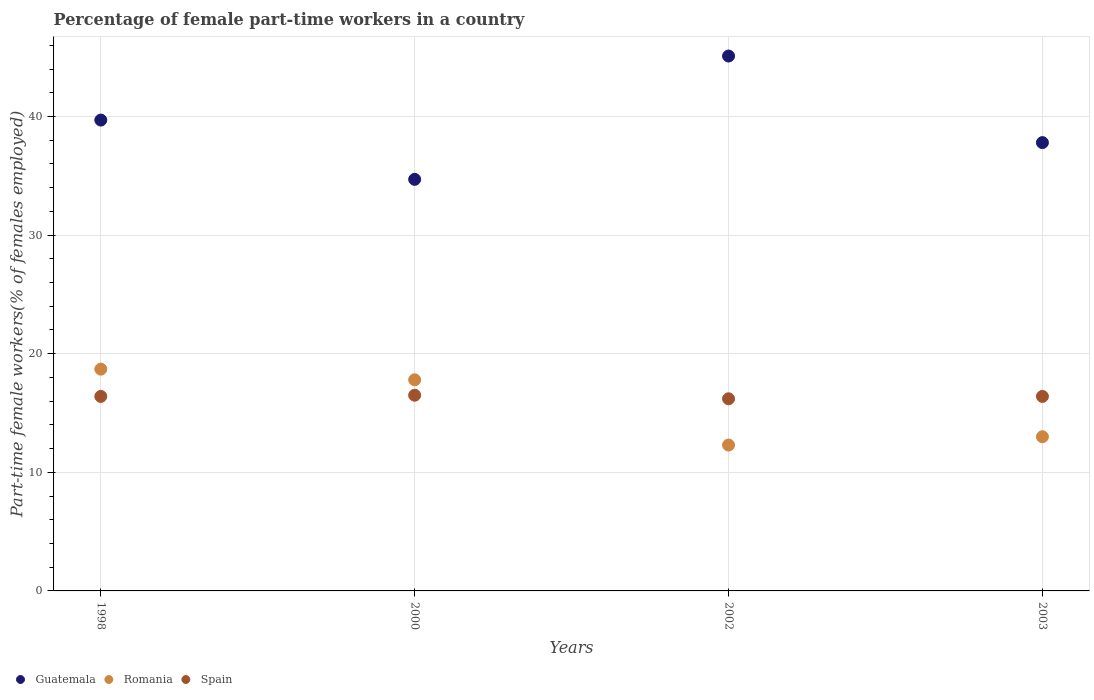What is the percentage of female part-time workers in Guatemala in 2000?
Offer a very short reply. 34.7. Across all years, what is the maximum percentage of female part-time workers in Romania?
Make the answer very short. 18.7. Across all years, what is the minimum percentage of female part-time workers in Guatemala?
Your response must be concise. 34.7. In which year was the percentage of female part-time workers in Guatemala minimum?
Provide a succinct answer. 2000. What is the total percentage of female part-time workers in Spain in the graph?
Provide a succinct answer. 65.5. What is the difference between the percentage of female part-time workers in Romania in 1998 and that in 2003?
Offer a very short reply. 5.7. What is the difference between the percentage of female part-time workers in Spain in 2002 and the percentage of female part-time workers in Romania in 2000?
Your answer should be compact. -1.6. What is the average percentage of female part-time workers in Romania per year?
Keep it short and to the point. 15.45. In the year 2002, what is the difference between the percentage of female part-time workers in Romania and percentage of female part-time workers in Guatemala?
Make the answer very short. -32.8. What is the ratio of the percentage of female part-time workers in Guatemala in 2002 to that in 2003?
Your response must be concise. 1.19. Is the percentage of female part-time workers in Guatemala in 1998 less than that in 2003?
Provide a short and direct response. No. What is the difference between the highest and the second highest percentage of female part-time workers in Spain?
Ensure brevity in your answer.  0.1. What is the difference between the highest and the lowest percentage of female part-time workers in Guatemala?
Offer a very short reply. 10.4. Is it the case that in every year, the sum of the percentage of female part-time workers in Spain and percentage of female part-time workers in Romania  is greater than the percentage of female part-time workers in Guatemala?
Offer a terse response. No. Is the percentage of female part-time workers in Spain strictly greater than the percentage of female part-time workers in Romania over the years?
Offer a terse response. No. How many years are there in the graph?
Make the answer very short. 4. Does the graph contain any zero values?
Your answer should be very brief. No. Where does the legend appear in the graph?
Give a very brief answer. Bottom left. What is the title of the graph?
Offer a very short reply. Percentage of female part-time workers in a country. Does "Ecuador" appear as one of the legend labels in the graph?
Offer a terse response. No. What is the label or title of the Y-axis?
Give a very brief answer. Part-time female workers(% of females employed). What is the Part-time female workers(% of females employed) of Guatemala in 1998?
Offer a very short reply. 39.7. What is the Part-time female workers(% of females employed) in Romania in 1998?
Provide a short and direct response. 18.7. What is the Part-time female workers(% of females employed) of Spain in 1998?
Your answer should be compact. 16.4. What is the Part-time female workers(% of females employed) in Guatemala in 2000?
Your answer should be compact. 34.7. What is the Part-time female workers(% of females employed) in Romania in 2000?
Offer a terse response. 17.8. What is the Part-time female workers(% of females employed) in Spain in 2000?
Your answer should be compact. 16.5. What is the Part-time female workers(% of females employed) of Guatemala in 2002?
Your answer should be compact. 45.1. What is the Part-time female workers(% of females employed) of Romania in 2002?
Keep it short and to the point. 12.3. What is the Part-time female workers(% of females employed) in Spain in 2002?
Give a very brief answer. 16.2. What is the Part-time female workers(% of females employed) of Guatemala in 2003?
Keep it short and to the point. 37.8. What is the Part-time female workers(% of females employed) in Spain in 2003?
Give a very brief answer. 16.4. Across all years, what is the maximum Part-time female workers(% of females employed) of Guatemala?
Give a very brief answer. 45.1. Across all years, what is the maximum Part-time female workers(% of females employed) of Romania?
Your answer should be compact. 18.7. Across all years, what is the minimum Part-time female workers(% of females employed) of Guatemala?
Ensure brevity in your answer.  34.7. Across all years, what is the minimum Part-time female workers(% of females employed) in Romania?
Offer a very short reply. 12.3. Across all years, what is the minimum Part-time female workers(% of females employed) of Spain?
Give a very brief answer. 16.2. What is the total Part-time female workers(% of females employed) in Guatemala in the graph?
Make the answer very short. 157.3. What is the total Part-time female workers(% of females employed) in Romania in the graph?
Make the answer very short. 61.8. What is the total Part-time female workers(% of females employed) of Spain in the graph?
Your answer should be compact. 65.5. What is the difference between the Part-time female workers(% of females employed) in Romania in 1998 and that in 2002?
Your answer should be compact. 6.4. What is the difference between the Part-time female workers(% of females employed) in Guatemala in 1998 and that in 2003?
Provide a short and direct response. 1.9. What is the difference between the Part-time female workers(% of females employed) in Spain in 1998 and that in 2003?
Your response must be concise. 0. What is the difference between the Part-time female workers(% of females employed) of Guatemala in 2000 and that in 2002?
Provide a succinct answer. -10.4. What is the difference between the Part-time female workers(% of females employed) of Romania in 2000 and that in 2002?
Keep it short and to the point. 5.5. What is the difference between the Part-time female workers(% of females employed) of Spain in 2000 and that in 2002?
Provide a succinct answer. 0.3. What is the difference between the Part-time female workers(% of females employed) of Guatemala in 2002 and that in 2003?
Your answer should be compact. 7.3. What is the difference between the Part-time female workers(% of females employed) of Romania in 2002 and that in 2003?
Provide a short and direct response. -0.7. What is the difference between the Part-time female workers(% of females employed) in Spain in 2002 and that in 2003?
Your response must be concise. -0.2. What is the difference between the Part-time female workers(% of females employed) in Guatemala in 1998 and the Part-time female workers(% of females employed) in Romania in 2000?
Offer a terse response. 21.9. What is the difference between the Part-time female workers(% of females employed) of Guatemala in 1998 and the Part-time female workers(% of females employed) of Spain in 2000?
Offer a terse response. 23.2. What is the difference between the Part-time female workers(% of females employed) in Guatemala in 1998 and the Part-time female workers(% of females employed) in Romania in 2002?
Your answer should be very brief. 27.4. What is the difference between the Part-time female workers(% of females employed) in Guatemala in 1998 and the Part-time female workers(% of females employed) in Spain in 2002?
Give a very brief answer. 23.5. What is the difference between the Part-time female workers(% of females employed) in Romania in 1998 and the Part-time female workers(% of females employed) in Spain in 2002?
Your answer should be very brief. 2.5. What is the difference between the Part-time female workers(% of females employed) in Guatemala in 1998 and the Part-time female workers(% of females employed) in Romania in 2003?
Offer a terse response. 26.7. What is the difference between the Part-time female workers(% of females employed) in Guatemala in 1998 and the Part-time female workers(% of females employed) in Spain in 2003?
Make the answer very short. 23.3. What is the difference between the Part-time female workers(% of females employed) in Guatemala in 2000 and the Part-time female workers(% of females employed) in Romania in 2002?
Your answer should be very brief. 22.4. What is the difference between the Part-time female workers(% of females employed) of Guatemala in 2000 and the Part-time female workers(% of females employed) of Spain in 2002?
Make the answer very short. 18.5. What is the difference between the Part-time female workers(% of females employed) in Romania in 2000 and the Part-time female workers(% of females employed) in Spain in 2002?
Make the answer very short. 1.6. What is the difference between the Part-time female workers(% of females employed) in Guatemala in 2000 and the Part-time female workers(% of females employed) in Romania in 2003?
Keep it short and to the point. 21.7. What is the difference between the Part-time female workers(% of females employed) of Guatemala in 2000 and the Part-time female workers(% of females employed) of Spain in 2003?
Ensure brevity in your answer.  18.3. What is the difference between the Part-time female workers(% of females employed) of Guatemala in 2002 and the Part-time female workers(% of females employed) of Romania in 2003?
Your response must be concise. 32.1. What is the difference between the Part-time female workers(% of females employed) in Guatemala in 2002 and the Part-time female workers(% of females employed) in Spain in 2003?
Your answer should be very brief. 28.7. What is the difference between the Part-time female workers(% of females employed) in Romania in 2002 and the Part-time female workers(% of females employed) in Spain in 2003?
Your answer should be very brief. -4.1. What is the average Part-time female workers(% of females employed) of Guatemala per year?
Provide a succinct answer. 39.33. What is the average Part-time female workers(% of females employed) of Romania per year?
Your answer should be compact. 15.45. What is the average Part-time female workers(% of females employed) in Spain per year?
Your answer should be compact. 16.38. In the year 1998, what is the difference between the Part-time female workers(% of females employed) of Guatemala and Part-time female workers(% of females employed) of Spain?
Your answer should be compact. 23.3. In the year 2000, what is the difference between the Part-time female workers(% of females employed) in Guatemala and Part-time female workers(% of females employed) in Romania?
Make the answer very short. 16.9. In the year 2002, what is the difference between the Part-time female workers(% of females employed) of Guatemala and Part-time female workers(% of females employed) of Romania?
Keep it short and to the point. 32.8. In the year 2002, what is the difference between the Part-time female workers(% of females employed) in Guatemala and Part-time female workers(% of females employed) in Spain?
Ensure brevity in your answer.  28.9. In the year 2002, what is the difference between the Part-time female workers(% of females employed) of Romania and Part-time female workers(% of females employed) of Spain?
Provide a succinct answer. -3.9. In the year 2003, what is the difference between the Part-time female workers(% of females employed) of Guatemala and Part-time female workers(% of females employed) of Romania?
Your answer should be compact. 24.8. In the year 2003, what is the difference between the Part-time female workers(% of females employed) in Guatemala and Part-time female workers(% of females employed) in Spain?
Offer a terse response. 21.4. What is the ratio of the Part-time female workers(% of females employed) of Guatemala in 1998 to that in 2000?
Provide a short and direct response. 1.14. What is the ratio of the Part-time female workers(% of females employed) in Romania in 1998 to that in 2000?
Ensure brevity in your answer.  1.05. What is the ratio of the Part-time female workers(% of females employed) of Guatemala in 1998 to that in 2002?
Ensure brevity in your answer.  0.88. What is the ratio of the Part-time female workers(% of females employed) in Romania in 1998 to that in 2002?
Offer a very short reply. 1.52. What is the ratio of the Part-time female workers(% of females employed) in Spain in 1998 to that in 2002?
Keep it short and to the point. 1.01. What is the ratio of the Part-time female workers(% of females employed) of Guatemala in 1998 to that in 2003?
Offer a terse response. 1.05. What is the ratio of the Part-time female workers(% of females employed) of Romania in 1998 to that in 2003?
Give a very brief answer. 1.44. What is the ratio of the Part-time female workers(% of females employed) in Guatemala in 2000 to that in 2002?
Your answer should be compact. 0.77. What is the ratio of the Part-time female workers(% of females employed) in Romania in 2000 to that in 2002?
Your answer should be compact. 1.45. What is the ratio of the Part-time female workers(% of females employed) in Spain in 2000 to that in 2002?
Your answer should be compact. 1.02. What is the ratio of the Part-time female workers(% of females employed) in Guatemala in 2000 to that in 2003?
Offer a very short reply. 0.92. What is the ratio of the Part-time female workers(% of females employed) of Romania in 2000 to that in 2003?
Give a very brief answer. 1.37. What is the ratio of the Part-time female workers(% of females employed) in Spain in 2000 to that in 2003?
Ensure brevity in your answer.  1.01. What is the ratio of the Part-time female workers(% of females employed) of Guatemala in 2002 to that in 2003?
Make the answer very short. 1.19. What is the ratio of the Part-time female workers(% of females employed) of Romania in 2002 to that in 2003?
Your answer should be compact. 0.95. What is the ratio of the Part-time female workers(% of females employed) of Spain in 2002 to that in 2003?
Provide a short and direct response. 0.99. What is the difference between the highest and the lowest Part-time female workers(% of females employed) in Romania?
Offer a very short reply. 6.4. What is the difference between the highest and the lowest Part-time female workers(% of females employed) in Spain?
Make the answer very short. 0.3. 